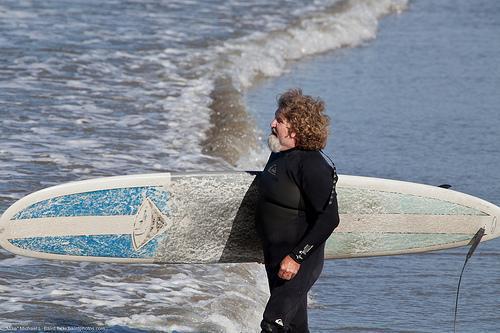How many men are there?
Give a very brief answer. 1. 